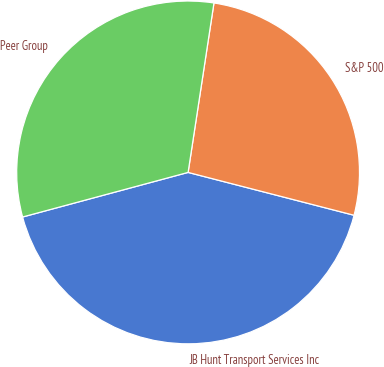Convert chart. <chart><loc_0><loc_0><loc_500><loc_500><pie_chart><fcel>JB Hunt Transport Services Inc<fcel>S&P 500<fcel>Peer Group<nl><fcel>41.79%<fcel>26.61%<fcel>31.6%<nl></chart> 